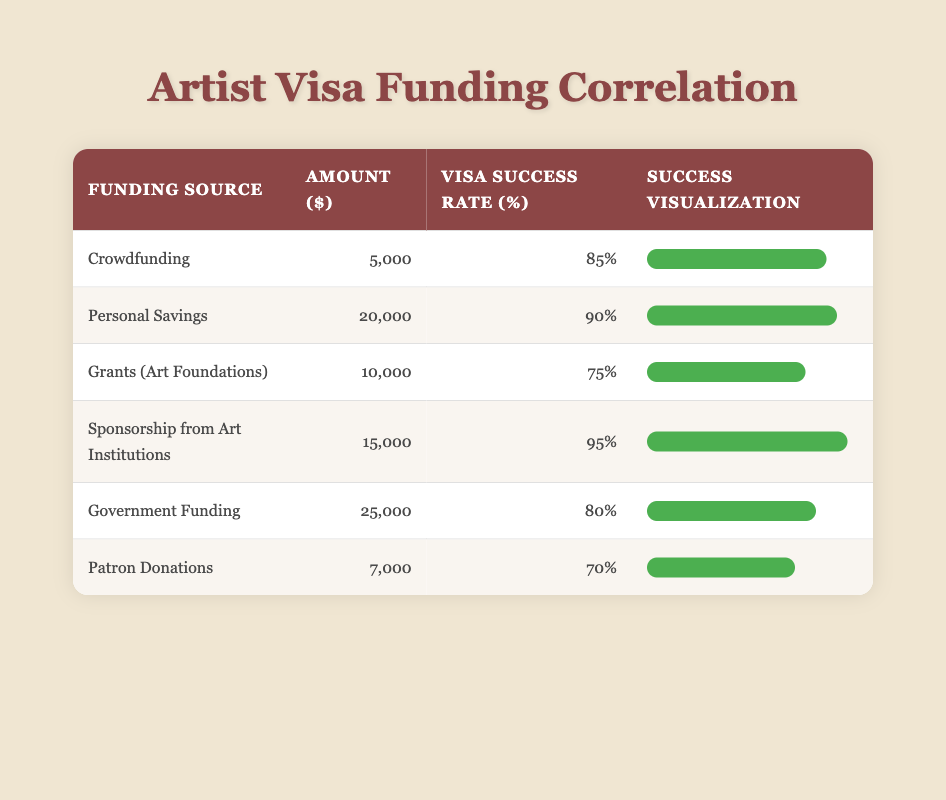What is the visa application success rate for Personal Savings? From the table, the row for Personal Savings shows a visa application success rate of 90%.
Answer: 90% Which funding source has the lowest visa success rate? By examining the table, Patron Donations has the lowest visa success rate of 70%.
Answer: Patron Donations What is the total amount of funding from Grants (Art Foundations) and Government Funding combined? The amount for Grants (Art Foundations) is 10,000 and for Government Funding is 25,000. Adding these gives 10,000 + 25,000 = 35,000.
Answer: 35,000 Is the visa success rate for Sponsorship from Art Institutions greater than 80%? Looking at the table, the success rate for Sponsorship from Art Institutions is 95%, which is indeed greater than 80%.
Answer: Yes What is the average visa success rate for all the funding sources listed? To find the average success rate, add all the success rates (85 + 90 + 75 + 95 + 80 + 70 = 495) and divide by the number of sources (6). Therefore, 495/6 = 82.5.
Answer: 82.5 Which funding source provides both the highest amount and the highest visa success rate? The table shows that Government Funding provides the highest amount at 25,000, but the highest visa success rate is for Sponsorship from Art Institutions at 95%. Therefore, the highest amount does not coincide with the highest success rate.
Answer: No source has both the highest amount and success rate What is the difference in visa success rates between Personal Savings and Patron Donations? The success rate for Personal Savings is 90%, while for Patron Donations it is 70%. The difference is 90 - 70 = 20.
Answer: 20 If the amounts provided were doubled for each funding source, what would be the new amount for Crowdfunding? The current amount for Crowdfunding is 5,000. If doubled, it would be 5,000 x 2 = 10,000.
Answer: 10,000 